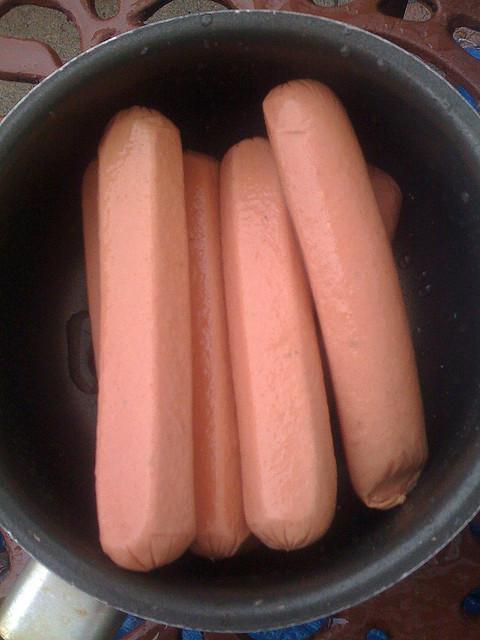How many hot dogs?
Give a very brief answer. 6. How many hot dogs are in the picture?
Give a very brief answer. 6. How many people are in the photo?
Give a very brief answer. 0. 